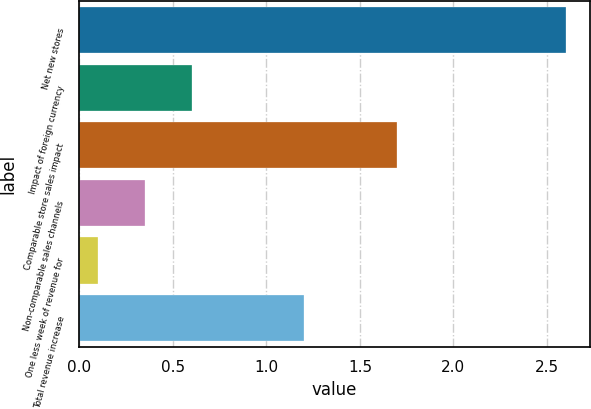Convert chart. <chart><loc_0><loc_0><loc_500><loc_500><bar_chart><fcel>Net new stores<fcel>Impact of foreign currency<fcel>Comparable store sales impact<fcel>Non-comparable sales channels<fcel>One less week of revenue for<fcel>Total revenue increase<nl><fcel>2.6<fcel>0.6<fcel>1.7<fcel>0.35<fcel>0.1<fcel>1.2<nl></chart> 